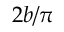Convert formula to latex. <formula><loc_0><loc_0><loc_500><loc_500>2 b / \pi</formula> 